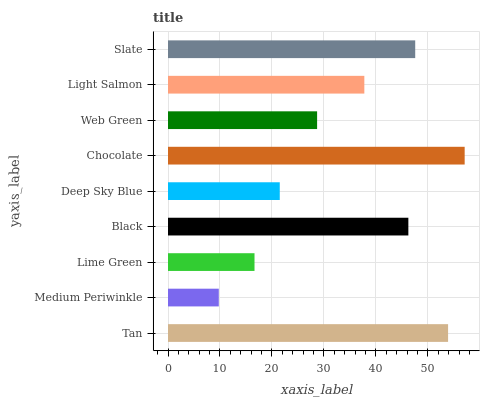Is Medium Periwinkle the minimum?
Answer yes or no. Yes. Is Chocolate the maximum?
Answer yes or no. Yes. Is Lime Green the minimum?
Answer yes or no. No. Is Lime Green the maximum?
Answer yes or no. No. Is Lime Green greater than Medium Periwinkle?
Answer yes or no. Yes. Is Medium Periwinkle less than Lime Green?
Answer yes or no. Yes. Is Medium Periwinkle greater than Lime Green?
Answer yes or no. No. Is Lime Green less than Medium Periwinkle?
Answer yes or no. No. Is Light Salmon the high median?
Answer yes or no. Yes. Is Light Salmon the low median?
Answer yes or no. Yes. Is Black the high median?
Answer yes or no. No. Is Tan the low median?
Answer yes or no. No. 